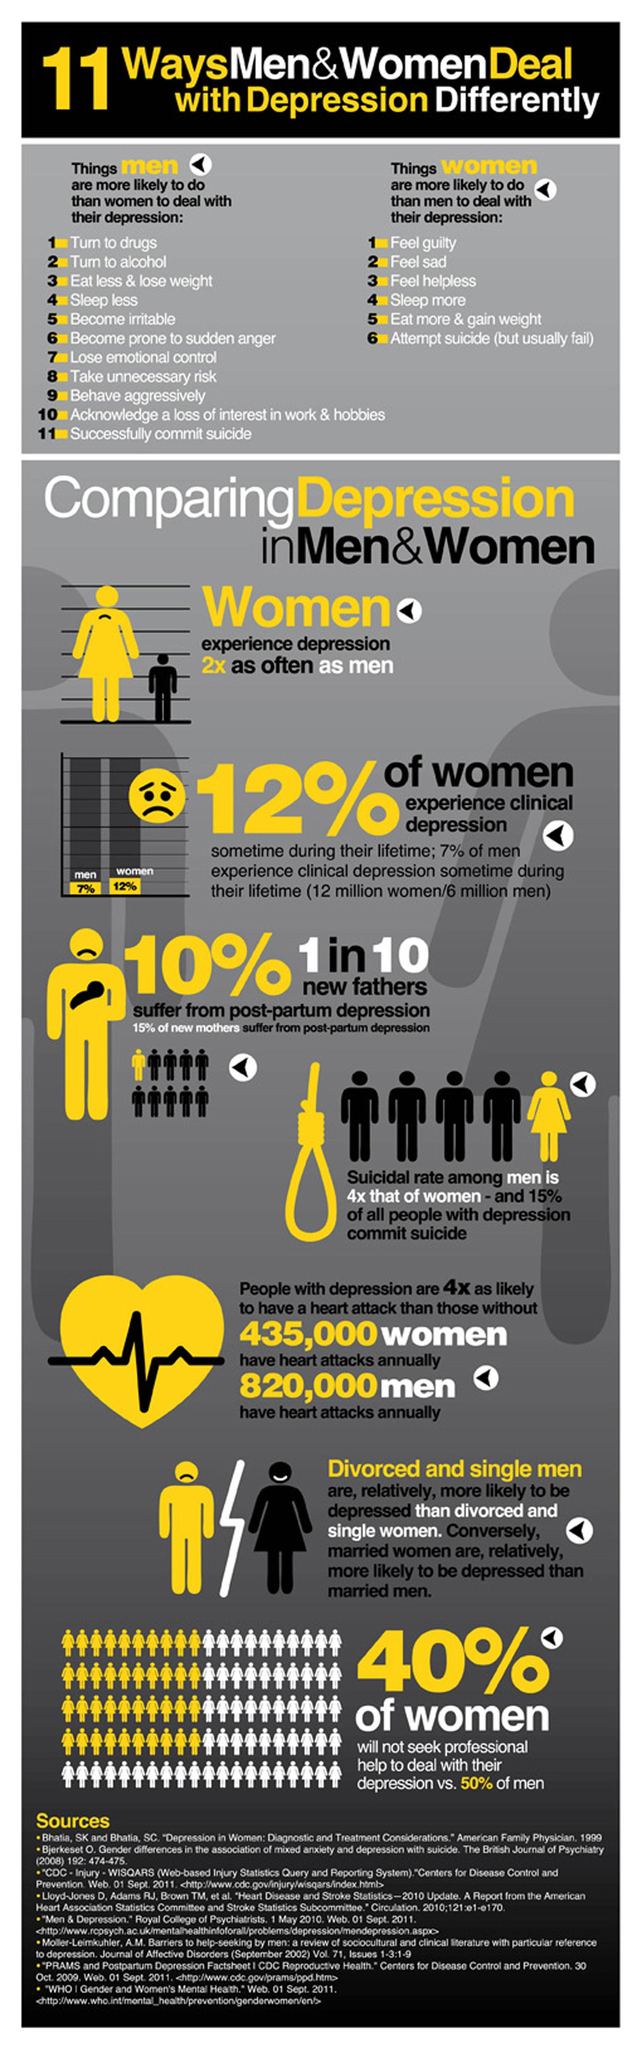Identify some key points in this picture. According to recent statistics, an estimated 12 million women in the United States have experienced clinical depression at least once in their lifetime. According to a recent survey, approximately 40% of women are against seeking professional help to deal with depression. Among these populations, the suicide rate is higher among men than among women. According to the data, approximately 60% of women are prepared to seek professional assistance to manage their depression symptoms. It is more common for new mothers to experience postpartum depression than for new fathers to do so. 